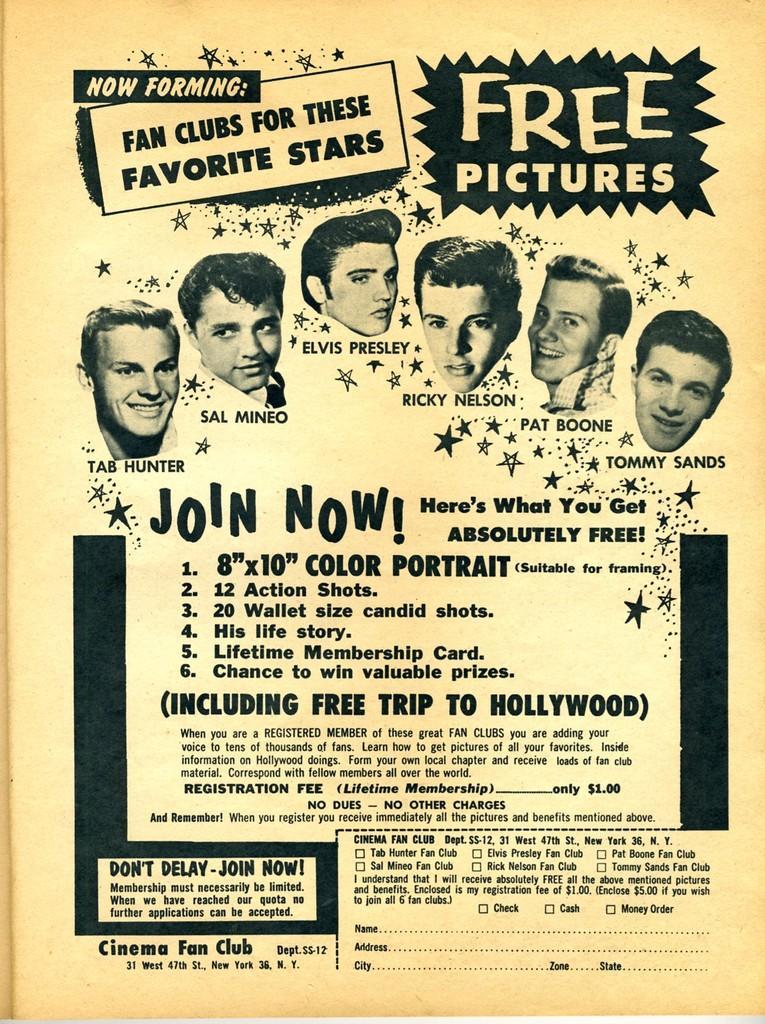Could you give a brief overview of what you see in this image? In the foreground of this poster, there are images of person´s head and we can also see some text in it. 